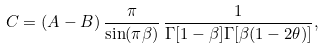Convert formula to latex. <formula><loc_0><loc_0><loc_500><loc_500>C = ( A - B ) \, \frac { \pi } { \sin ( \pi \beta ) } \, \frac { 1 } { \Gamma [ 1 - \beta ] \Gamma [ \beta ( 1 - 2 \theta ) ] } ,</formula> 